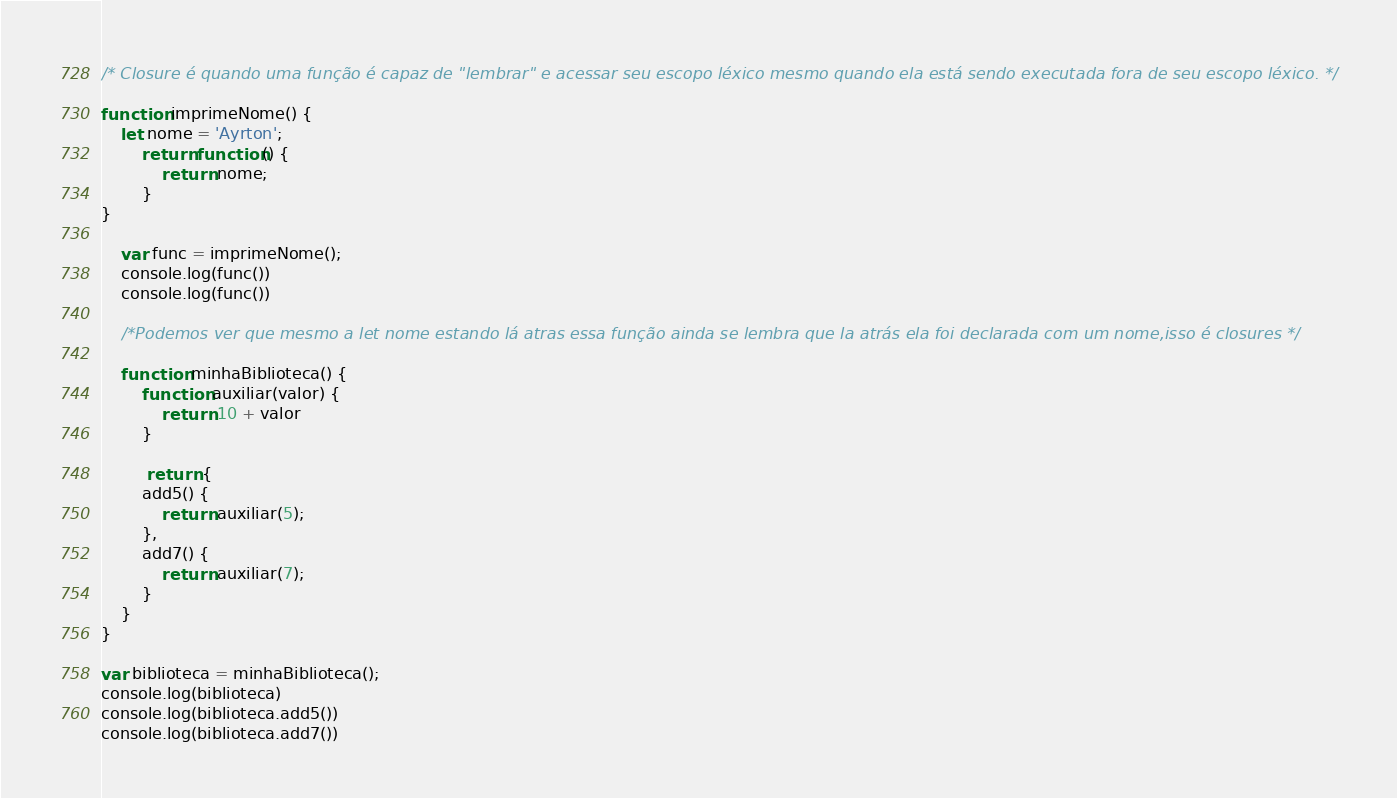Convert code to text. <code><loc_0><loc_0><loc_500><loc_500><_JavaScript_>/* Closure é quando uma função é capaz de "lembrar" e acessar seu escopo léxico mesmo quando ela está sendo executada fora de seu escopo léxico. */

function imprimeNome() {
    let nome = 'Ayrton';
        return function() {
            return nome;
        }
}

    var func = imprimeNome();
    console.log(func())
    console.log(func()) 

    /*Podemos ver que mesmo a let nome estando lá atras essa função ainda se lembra que la atrás ela foi declarada com um nome,isso é closures */

    function minhaBiblioteca() {
        function auxiliar(valor) {
            return 10 + valor
        }

         return {
        add5() {
            return auxiliar(5);
        },
        add7() {
            return auxiliar(7);
        }
    }
}

var biblioteca = minhaBiblioteca();
console.log(biblioteca)
console.log(biblioteca.add5())
console.log(biblioteca.add7())

</code> 